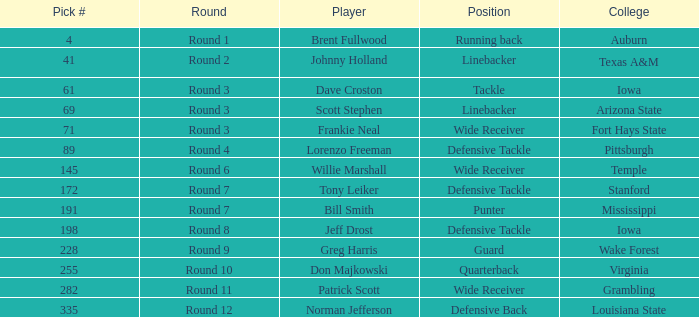Which round goes to Stanford college? Round 7. 